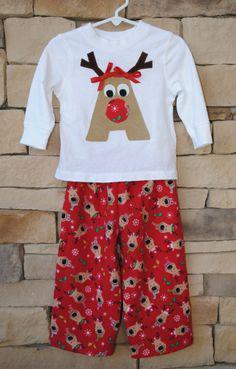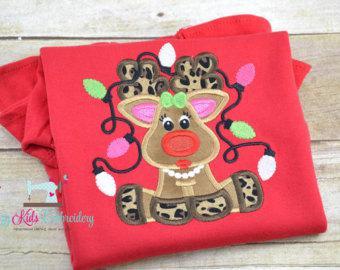The first image is the image on the left, the second image is the image on the right. Examine the images to the left and right. Is the description "There is a reindeer on at least one of the shirts." accurate? Answer yes or no. Yes. The first image is the image on the left, the second image is the image on the right. Evaluate the accuracy of this statement regarding the images: "One image shows a mostly white top paired with red pants that have white polka dots.". Is it true? Answer yes or no. No. 